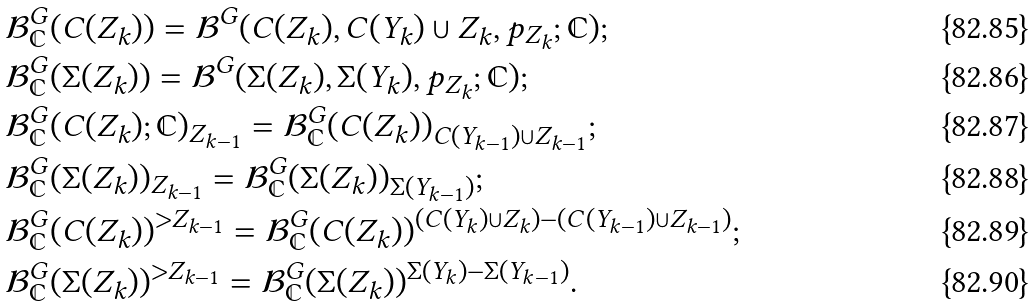Convert formula to latex. <formula><loc_0><loc_0><loc_500><loc_500>& \mathcal { B } ^ { G } _ { \mathbb { C } } ( C ( Z _ { k } ) ) = \mathcal { B } ^ { G } ( C ( Z _ { k } ) , C ( Y _ { k } ) \cup Z _ { k } , p _ { Z _ { k } } ; \mathbb { C } ) ; \\ & \mathcal { B } ^ { G } _ { \mathbb { C } } ( \Sigma ( Z _ { k } ) ) = \mathcal { B } ^ { G } ( \Sigma ( Z _ { k } ) , \Sigma ( Y _ { k } ) , p _ { Z _ { k } } ; \mathbb { C } ) ; \\ & \mathcal { B } ^ { G } _ { \mathbb { C } } ( C ( Z _ { k } ) ; \mathbb { C } ) _ { Z _ { k - 1 } } = \mathcal { B } ^ { G } _ { \mathbb { C } } ( C ( Z _ { k } ) ) _ { C ( Y _ { k - 1 } ) \cup Z _ { k - 1 } } ; \\ & \mathcal { B } ^ { G } _ { \mathbb { C } } ( \Sigma ( Z _ { k } ) ) _ { Z _ { k - 1 } } = \mathcal { B } ^ { G } _ { \mathbb { C } } ( \Sigma ( Z _ { k } ) ) _ { \Sigma ( Y _ { k - 1 } ) } ; \\ & \mathcal { B } ^ { G } _ { \mathbb { C } } ( C ( Z _ { k } ) ) ^ { > Z _ { k - 1 } } = \mathcal { B } ^ { G } _ { \mathbb { C } } ( C ( Z _ { k } ) ) ^ { ( C ( Y _ { k } ) \cup Z _ { k } ) - ( C ( Y _ { k - 1 } ) \cup Z _ { k - 1 } ) } ; \\ & \mathcal { B } ^ { G } _ { \mathbb { C } } ( \Sigma ( Z _ { k } ) ) ^ { > Z _ { k - 1 } } = \mathcal { B } ^ { G } _ { \mathbb { C } } ( \Sigma ( Z _ { k } ) ) ^ { \Sigma ( Y _ { k } ) - \Sigma ( Y _ { k - 1 } ) } .</formula> 